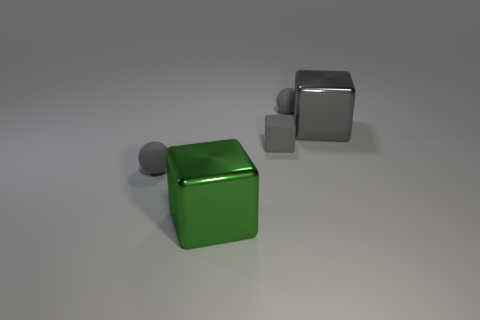What shape is the gray object that is the same size as the green object?
Your answer should be very brief. Cube. Are there any other things that have the same size as the green cube?
Keep it short and to the point. Yes. What is the material of the big cube behind the small gray ball left of the big green object?
Keep it short and to the point. Metal. Is the size of the green thing the same as the gray metal thing?
Your answer should be very brief. Yes. What number of objects are either big cubes that are right of the big green block or tiny brown blocks?
Offer a very short reply. 1. There is a object to the left of the metallic object that is to the left of the large gray object; what is its shape?
Your answer should be compact. Sphere. There is a gray metallic block; is its size the same as the green metallic object in front of the gray rubber block?
Your answer should be very brief. Yes. There is a tiny gray ball that is right of the large green thing; what is its material?
Provide a succinct answer. Rubber. How many big cubes are behind the green block and on the left side of the big gray metallic block?
Offer a terse response. 0. What material is the gray thing that is the same size as the green shiny thing?
Your answer should be very brief. Metal. 